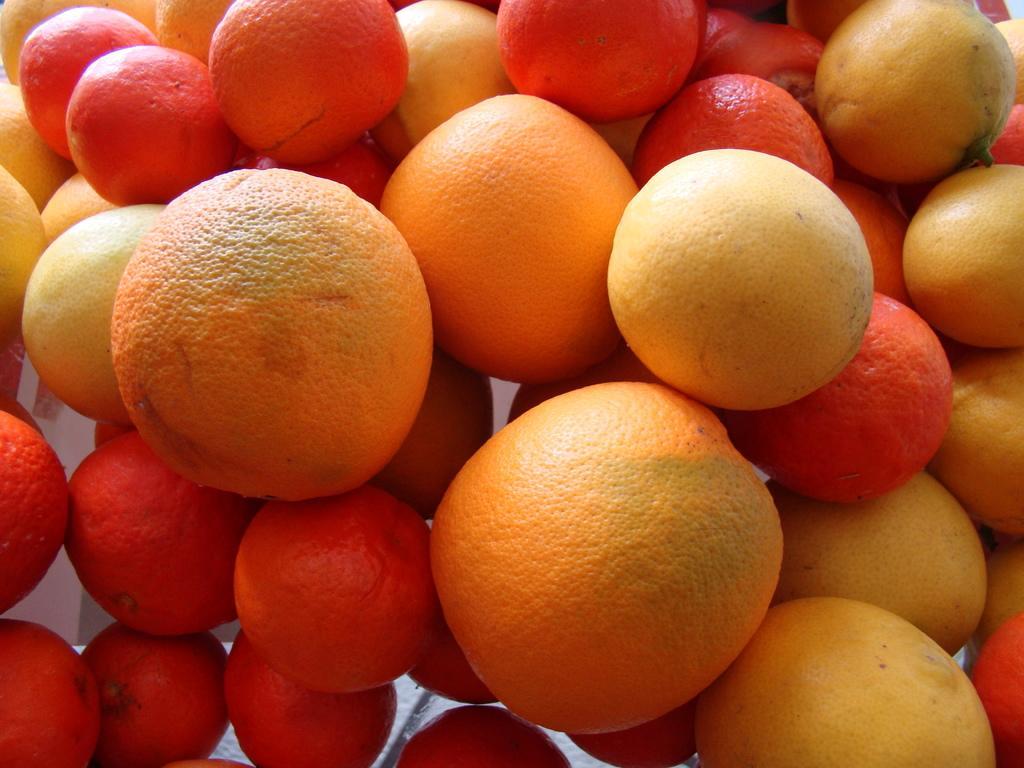Describe this image in one or two sentences. In this picture I can see a number of fruits. 